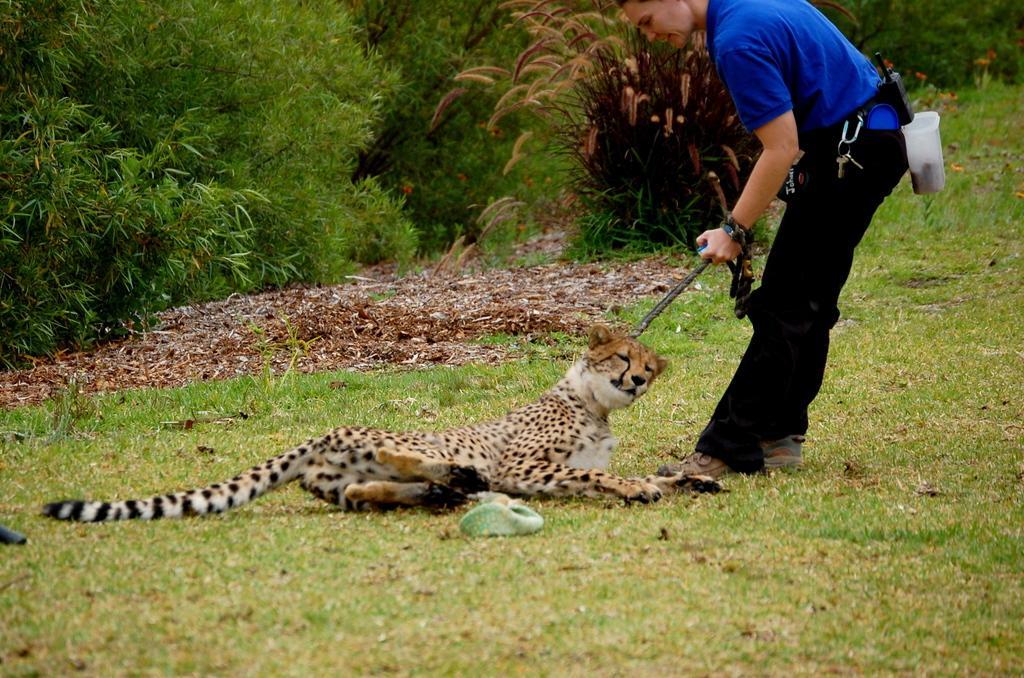Can you describe this image briefly? In this image we can see a Leopard on the surface of the grass, in front of the Leopard there is a person standing with a stick in his hand, behind them there are trees. 